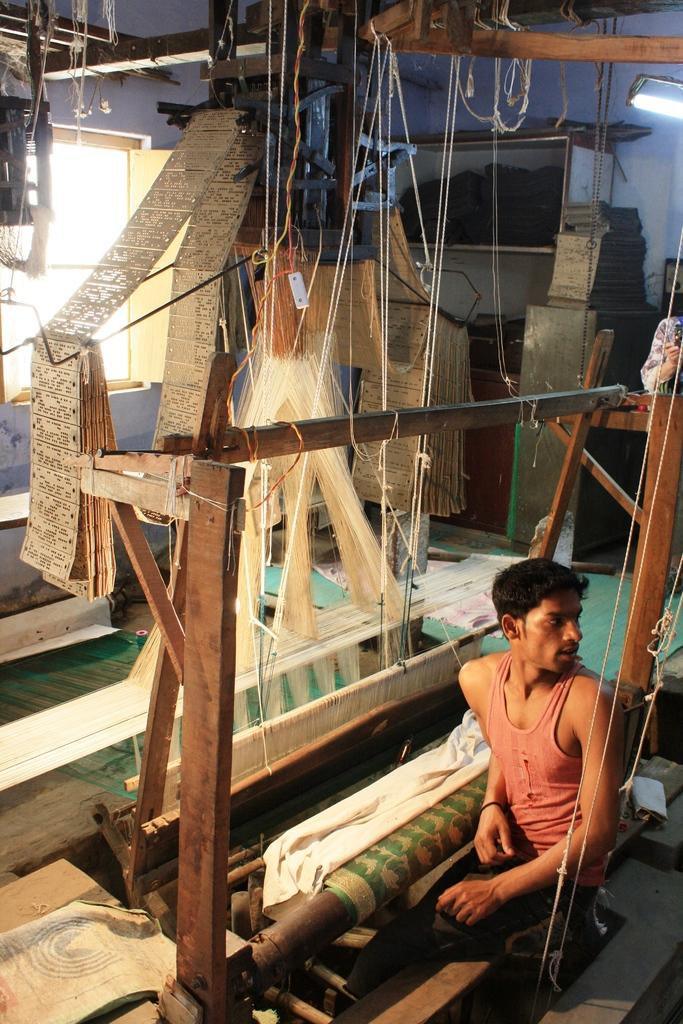What is the main object in the image? There is a weaving set in the image. Where is the weaving set located? The weaving set is in a home. Who is present in the image? There is a man sitting near the weaving set. What is the man doing in the image? The man is turning back. What can be seen in the background of the image? There is a wall in the background of the image, and a light is attached to the wall. What type of care does the man provide for the weaving set in the image? There is no indication in the image that the man is providing care for the weaving set. What is the reason behind the man's action of turning back in the image? The image does not provide any information about the man's reason for turning back. 